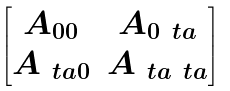Convert formula to latex. <formula><loc_0><loc_0><loc_500><loc_500>\begin{bmatrix} A _ { 0 0 } & A _ { 0 \ t a } \\ A _ { \ t a 0 } & A _ { \ t a \ t a } \end{bmatrix}</formula> 